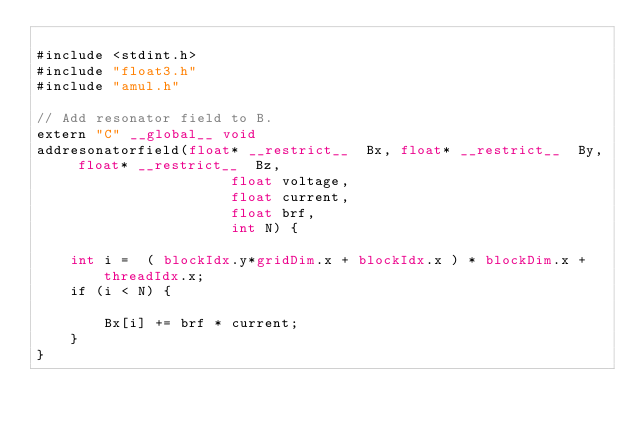Convert code to text. <code><loc_0><loc_0><loc_500><loc_500><_Cuda_>
#include <stdint.h>
#include "float3.h"
#include "amul.h"

// Add resonator field to B.
extern "C" __global__ void
addresonatorfield(float* __restrict__  Bx, float* __restrict__  By, float* __restrict__  Bz,
                       float voltage,
                       float current, 
                       float brf,
                       int N) {

    int i =  ( blockIdx.y*gridDim.x + blockIdx.x ) * blockDim.x + threadIdx.x;
    if (i < N) {

        Bx[i] += brf * current;
    }
}

</code> 